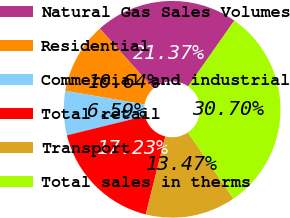<chart> <loc_0><loc_0><loc_500><loc_500><pie_chart><fcel>Natural Gas Sales Volumes<fcel>Residential<fcel>Commercial and industrial<fcel>Total retail<fcel>Transport<fcel>Total sales in therms<nl><fcel>21.37%<fcel>10.64%<fcel>6.59%<fcel>17.23%<fcel>13.47%<fcel>30.7%<nl></chart> 